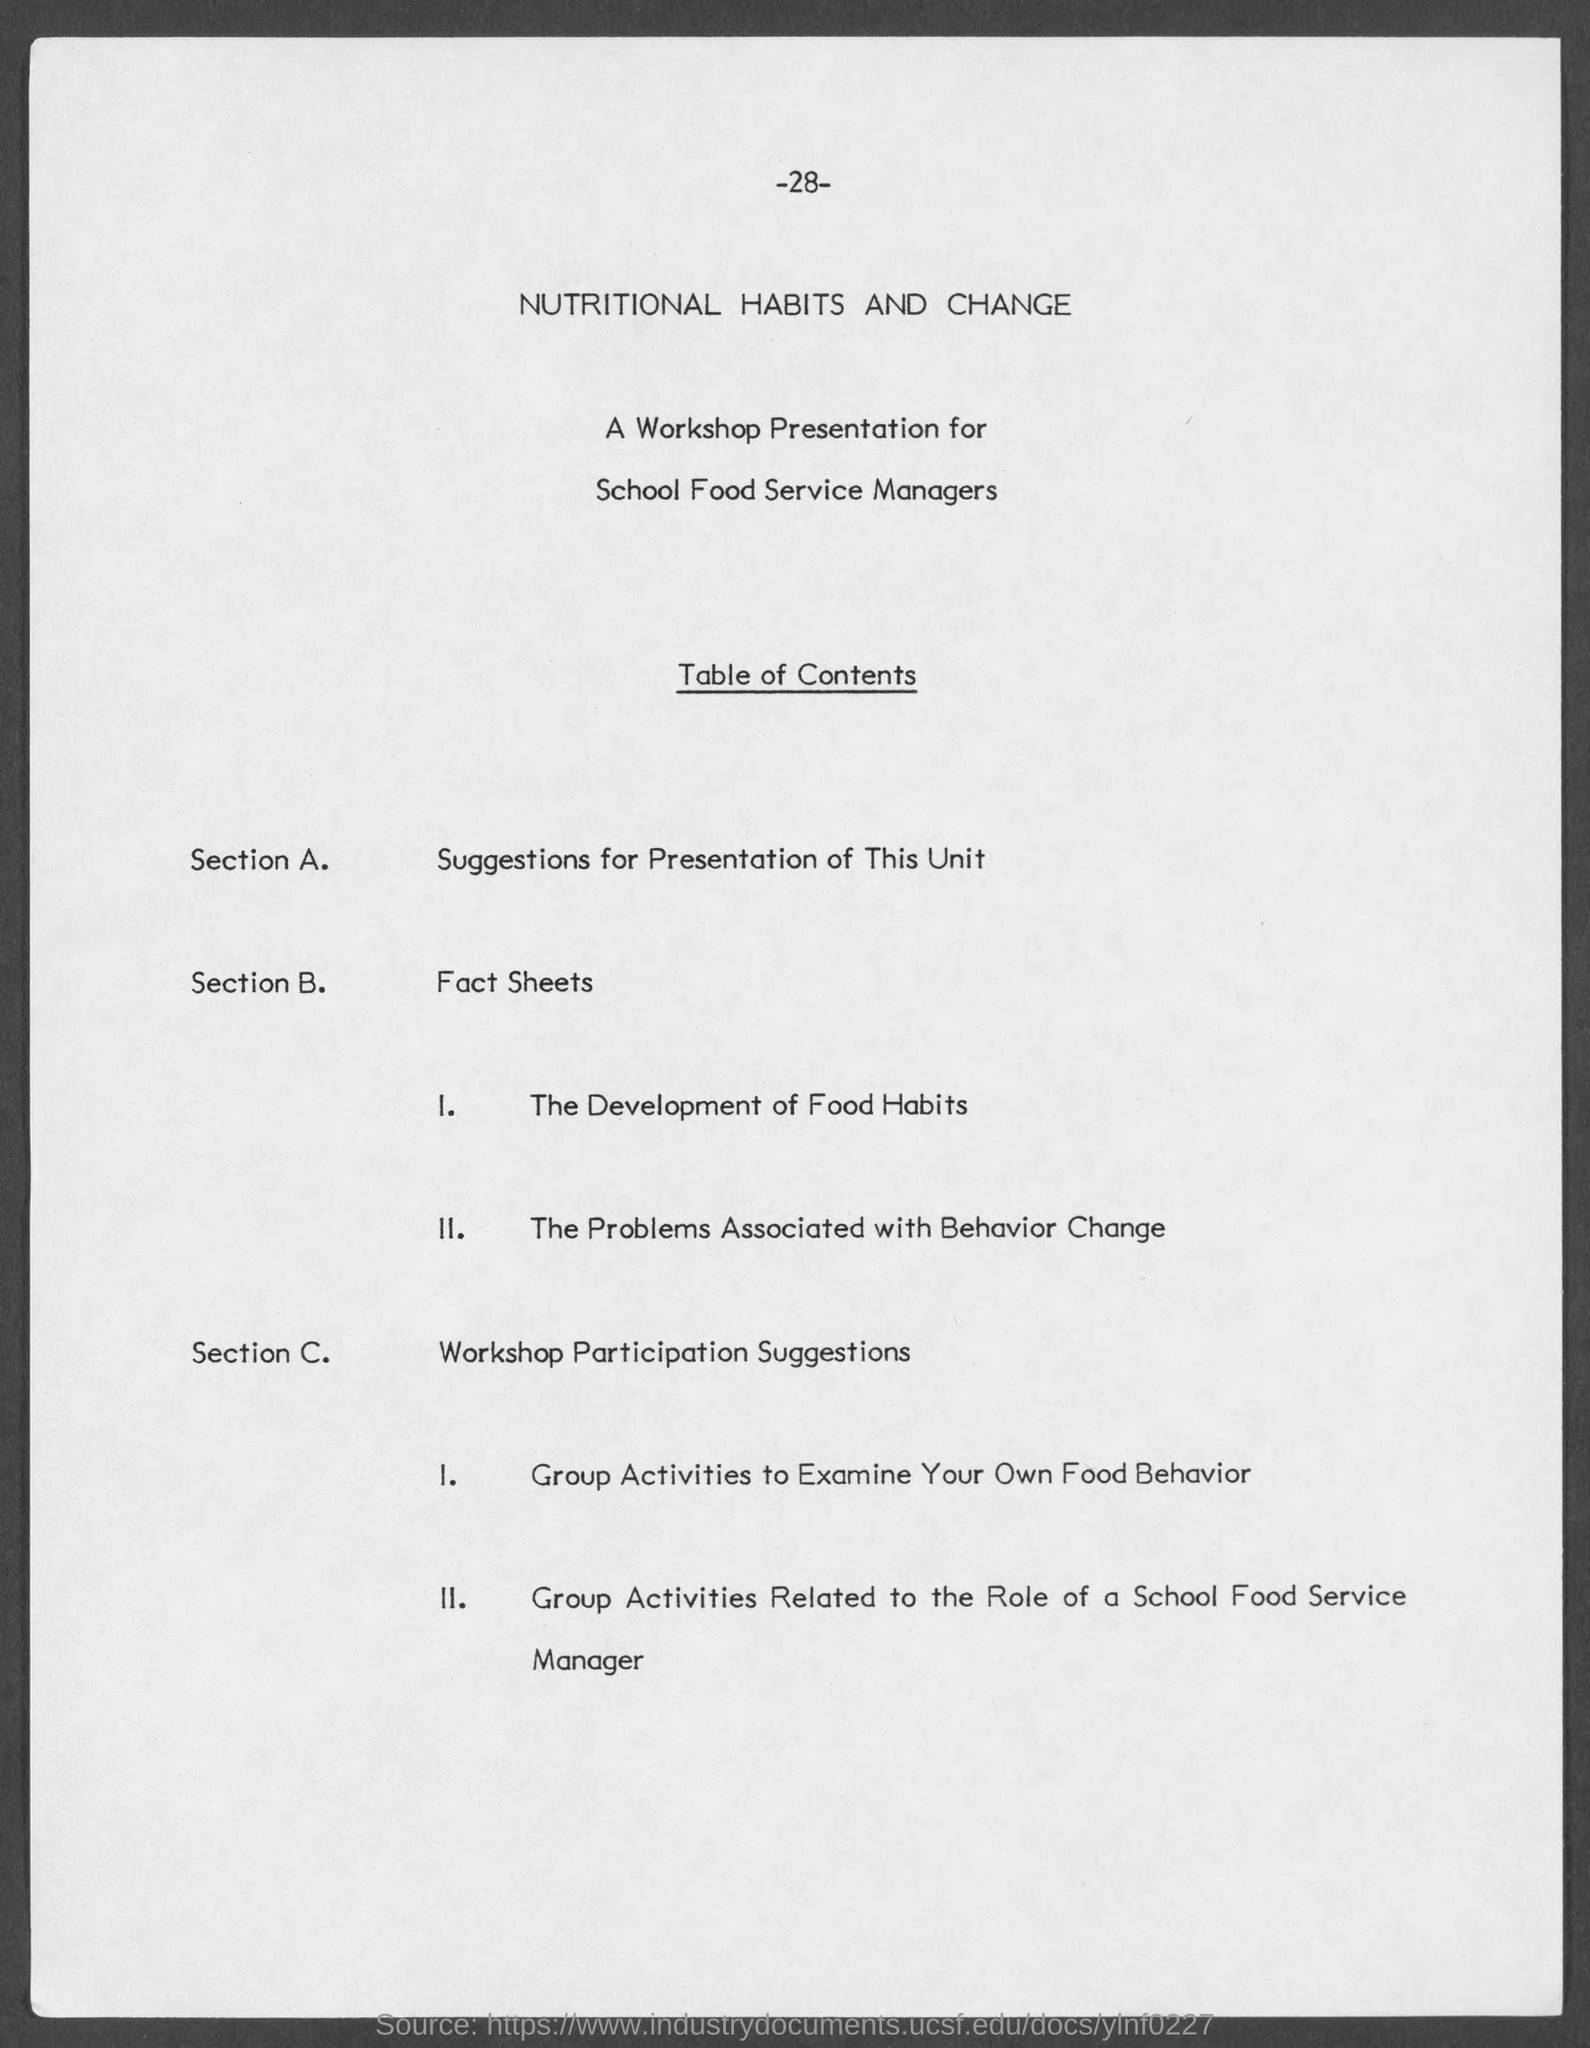What is the page number at top of the page?
Offer a very short reply. -28-. What does section a deals with ?
Give a very brief answer. Suggestions for Presentation of this Unit. What does section b deals with ?
Give a very brief answer. Fact sheets. What does section c deals with ?
Your answer should be compact. Workshop Participation Suggestions. 